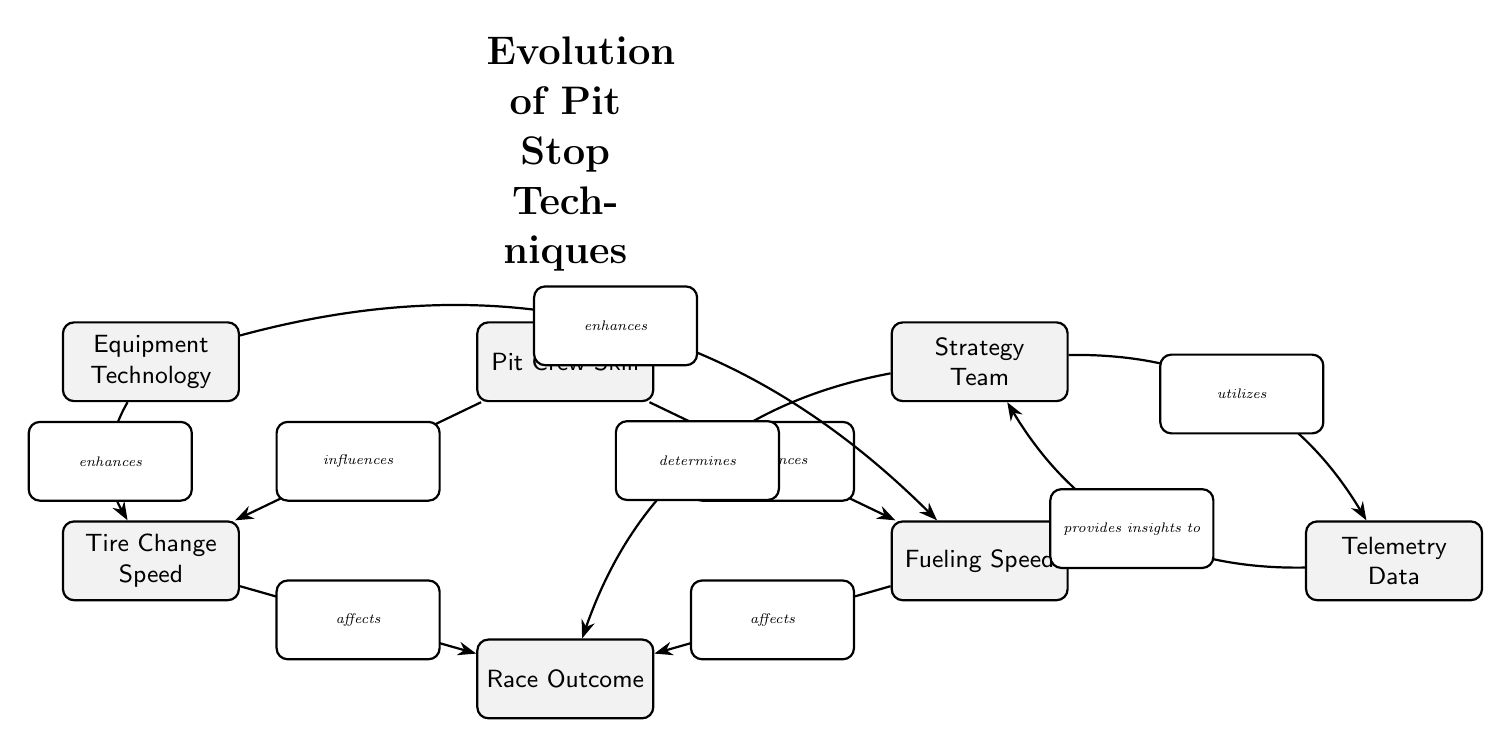What are the three factors influenced by Pit Crew Skill? The diagram shows three edges leading from "Pit Crew Skill" to "Fueling Speed," "Tire Change Speed," and "Race Outcome." However, the question specifically asks for factors influenced by "Pit Crew Skill." The two factors here are "Fueling Speed" and "Tire Change Speed."
Answer: Fueling Speed, Tire Change Speed Which node enhances both Fueling Speed and Tire Change Speed? The diagram indicates that "Equipment Technology" has edges that enhance both "Fueling Speed" and "Tire Change Speed." These connections illustrate how advancements in technology improve these two factors.
Answer: Equipment Technology How many total nodes are in the diagram? By counting the nodes shown in the diagram, we find six distinct nodes: "Pit Crew Skill," "Fueling Speed," "Tire Change Speed," "Equipment Technology," "Strategy Team," and "Telemetry Data." Adding "Race Outcome" gives us a total of seven nodes.
Answer: 7 What does the Strategy Team utilize to determine the Race Outcome? The "Strategy Team" node has an edge descending toward "Race Outcome," and connects to "Telemetry Data," which it utilizes for insights. Therefore, the "Strategy Team" uses "Telemetry Data" to inform its decisions regarding the race outcome.
Answer: Telemetry Data Which factor affects Race Outcome the most directly, according to the diagram? The edges from "Tire Change Speed" and "Fueling Speed" both affect "Race Outcome" directly. However, considering both factors influence the outcome, the diagram does not specify which has a greater impact. Thus, both factors affect "Race Outcome" directly.
Answer: Tire Change Speed, Fueling Speed How many edges are in the diagram? To find the number of edges, each connection between the nodes indicates an edge. Counting them yields six edges in total, which illustrates the interactions between the various aspects outlined in the diagram.
Answer: 6 Which node is specifically related to the speed of tire changes? In the diagram, the node "Tire Change Speed" directly relates to the speed of changing tires during a pit stop. It is one of the main factors influenced by "Pit Crew Skill."
Answer: Tire Change Speed What is the relationship between Telemetry Data and the Strategy Team? The diagram shows a bidirectional relationship where "Telemetry Data" provides insights to the "Strategy Team," and conversely, the "Strategy Team" also utilizes it. Therefore, this relationship is described as mutual or interdependent.
Answer: Provides insights to, utilizes What influences the fueling speed according to the diagram? The diagram reveals that "Pit Crew Skill" influences "Fueling Speed." Additionally, it shows that "Equipment Technology" enhances "Fueling Speed." These factors collaborate to impact how fuel is handled during pit stops.
Answer: Pit Crew Skill, Equipment Technology 